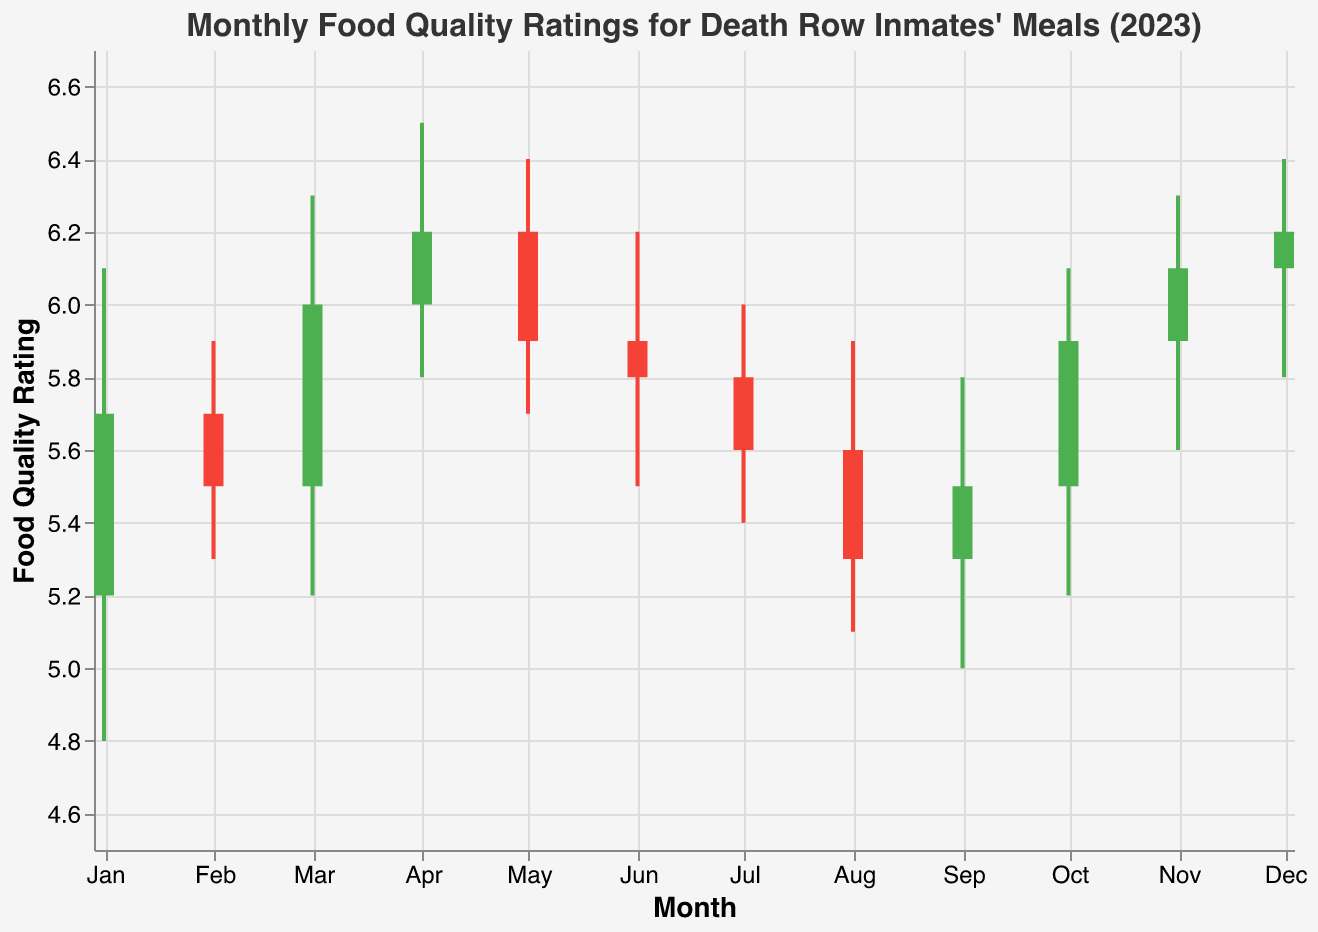What is the title of the chart? The title is displayed prominently at the top of the chart and provides context for what the chart represents.
Answer: Monthly Food Quality Ratings for Death Row Inmates' Meals (2023) What is the food quality rating for January 2023? The OHLC chart shows the food quality ratings including the open, high, low, and close values for each month. For January 2023, the rating closes at 5.7.
Answer: 5.7 Which month had the highest peak food quality rating? To find the highest peak rating, look for the highest "High" value on the y-axis. The highest is in April 2023 with a value of 6.5.
Answer: April 2023 What is the lowest food quality rating recorded in 2023? The lowest rating corresponds to the "Low" value in the chart, which is 4.8 in January 2023.
Answer: 4.8 Which month had the most significant drop in food quality from Open to Close? The most significant drop is represented by the largest negative difference between Open and Close values. For February 2023, the rating opens at 5.7 and closes at 5.5, a drop of 0.2. Observing all the months, August 2023 shows the largest drop from 5.6 to 5.3, a difference of 0.3 points.
Answer: August 2023 Was there an overall improvement or decline in food quality from January to December 2023? Comparing the opening rating of January (5.2) with the closing rating of December (6.2), there is an overall improvement of 1 point.
Answer: Improvement How many months had a closing rating higher than the opening? Months where Close is greater than Open are represented by green bars. These months include January, March, April, October, and November. That sums up to 5 months.
Answer: 5 months What was the range of food quality ratings in May 2023? The range is the difference between the highest and lowest values. For May 2023, the highest value is 6.4 and the lowest is 5.7. So the range is 6.4 - 5.7 = 0.7.
Answer: 0.7 By how much did the food quality rating improve or decline from March to April 2023? To find the change, subtract the closing value of March (6.0) from the closing value of April (6.2). The improvement is 6.2 - 6.0 = 0.2.
Answer: 0.2 